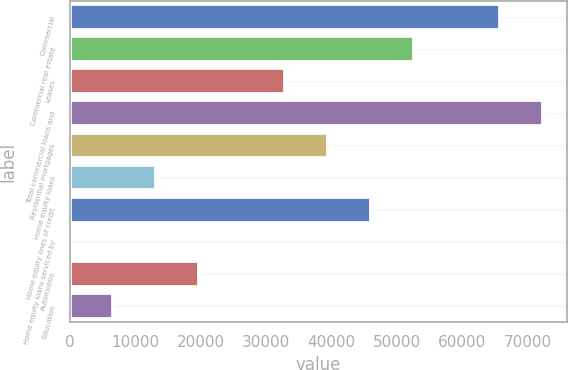<chart> <loc_0><loc_0><loc_500><loc_500><bar_chart><fcel>Commercial<fcel>Commercial real estate<fcel>Leases<fcel>Total commercial loans and<fcel>Residential mortgages<fcel>Home equity loans<fcel>Home equity lines of credit<fcel>Home equity loans serviced by<fcel>Automobile<fcel>Education<nl><fcel>65766<fcel>52613<fcel>32883.5<fcel>72342.5<fcel>39460<fcel>13154<fcel>46036.5<fcel>1<fcel>19730.5<fcel>6577.5<nl></chart> 